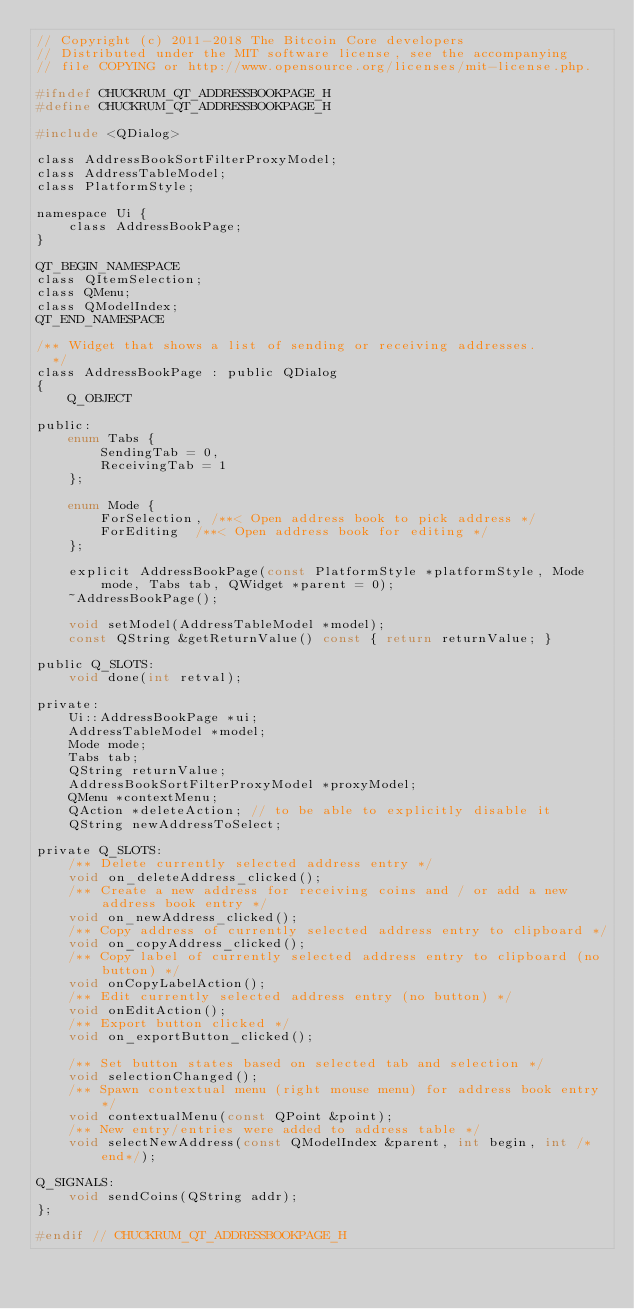<code> <loc_0><loc_0><loc_500><loc_500><_C_>// Copyright (c) 2011-2018 The Bitcoin Core developers
// Distributed under the MIT software license, see the accompanying
// file COPYING or http://www.opensource.org/licenses/mit-license.php.

#ifndef CHUCKRUM_QT_ADDRESSBOOKPAGE_H
#define CHUCKRUM_QT_ADDRESSBOOKPAGE_H

#include <QDialog>

class AddressBookSortFilterProxyModel;
class AddressTableModel;
class PlatformStyle;

namespace Ui {
    class AddressBookPage;
}

QT_BEGIN_NAMESPACE
class QItemSelection;
class QMenu;
class QModelIndex;
QT_END_NAMESPACE

/** Widget that shows a list of sending or receiving addresses.
  */
class AddressBookPage : public QDialog
{
    Q_OBJECT

public:
    enum Tabs {
        SendingTab = 0,
        ReceivingTab = 1
    };

    enum Mode {
        ForSelection, /**< Open address book to pick address */
        ForEditing  /**< Open address book for editing */
    };

    explicit AddressBookPage(const PlatformStyle *platformStyle, Mode mode, Tabs tab, QWidget *parent = 0);
    ~AddressBookPage();

    void setModel(AddressTableModel *model);
    const QString &getReturnValue() const { return returnValue; }

public Q_SLOTS:
    void done(int retval);

private:
    Ui::AddressBookPage *ui;
    AddressTableModel *model;
    Mode mode;
    Tabs tab;
    QString returnValue;
    AddressBookSortFilterProxyModel *proxyModel;
    QMenu *contextMenu;
    QAction *deleteAction; // to be able to explicitly disable it
    QString newAddressToSelect;

private Q_SLOTS:
    /** Delete currently selected address entry */
    void on_deleteAddress_clicked();
    /** Create a new address for receiving coins and / or add a new address book entry */
    void on_newAddress_clicked();
    /** Copy address of currently selected address entry to clipboard */
    void on_copyAddress_clicked();
    /** Copy label of currently selected address entry to clipboard (no button) */
    void onCopyLabelAction();
    /** Edit currently selected address entry (no button) */
    void onEditAction();
    /** Export button clicked */
    void on_exportButton_clicked();

    /** Set button states based on selected tab and selection */
    void selectionChanged();
    /** Spawn contextual menu (right mouse menu) for address book entry */
    void contextualMenu(const QPoint &point);
    /** New entry/entries were added to address table */
    void selectNewAddress(const QModelIndex &parent, int begin, int /*end*/);

Q_SIGNALS:
    void sendCoins(QString addr);
};

#endif // CHUCKRUM_QT_ADDRESSBOOKPAGE_H
</code> 